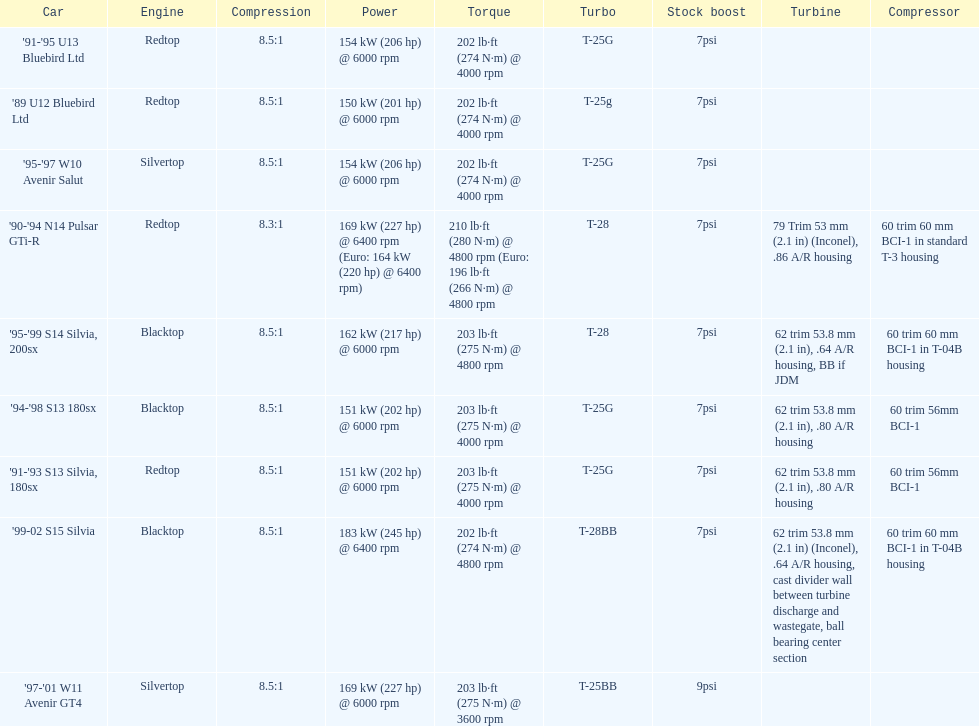Which engine has the smallest compression rate? '90-'94 N14 Pulsar GTi-R. 